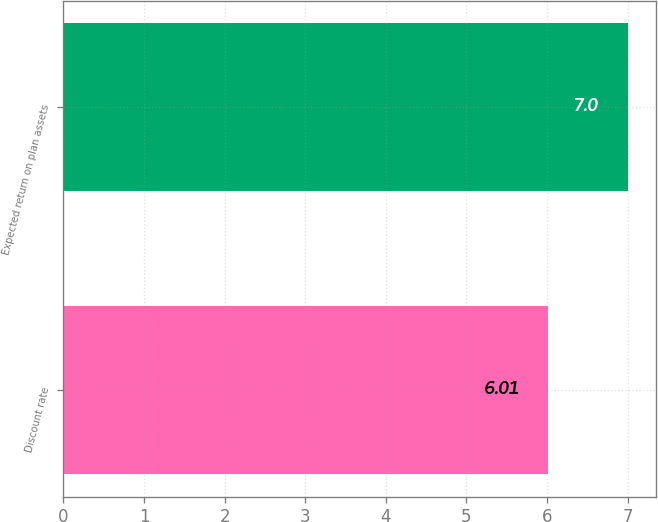Convert chart to OTSL. <chart><loc_0><loc_0><loc_500><loc_500><bar_chart><fcel>Discount rate<fcel>Expected return on plan assets<nl><fcel>6.01<fcel>7<nl></chart> 